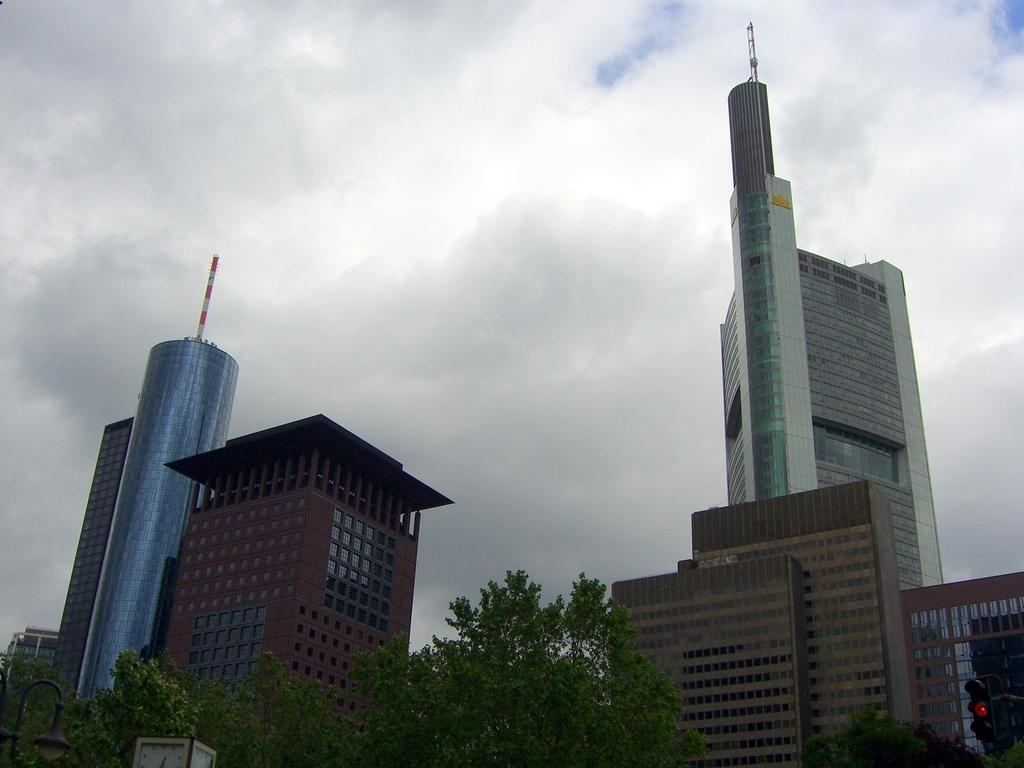What type of structures can be seen in the image? There are buildings in the image. What device is used to control traffic in the image? There is a traffic signal in the image. What is the source of illumination in the image? There is a light in the image. What type of vegetation can be seen in the image? There are branches and leaves in the image. What object is present in the image? There is an object in the image. What can be seen in the background of the image? The sky is visible in the background of the image. What are the clouds like in the sky? There are clouds in the sky. Can you tell me how many people are holding eggs in the image? There are no people or eggs present in the image. What type of neck accessory is worn by the branches in the image? There are no neck accessories in the image, as the branches are part of the vegetation. 